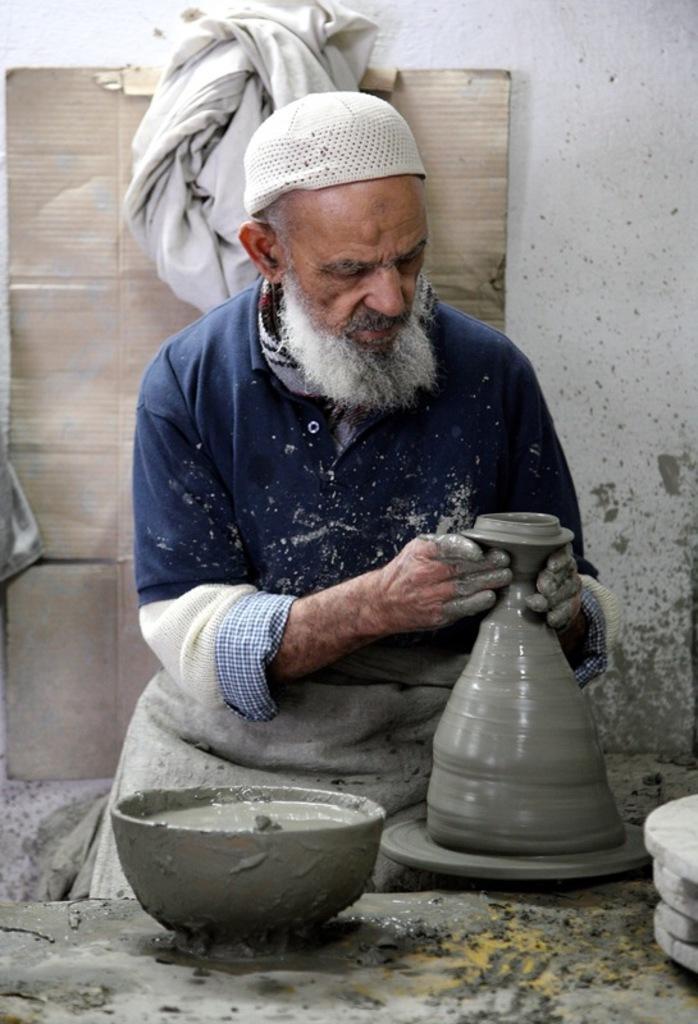Can you describe this image briefly? In the picture I can see a person wearing blue color sweater is holding an object made of mud. Here we can see mud kept in the bowl. In the background, I can see cardboard piece and a cloth are kept near the wall. 